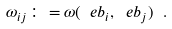<formula> <loc_0><loc_0><loc_500><loc_500>\omega _ { i j } \colon = \omega ( \ e b _ { i } , \ e b _ { j } ) \ .</formula> 